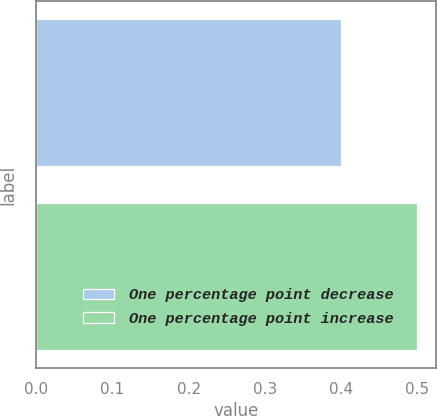Convert chart to OTSL. <chart><loc_0><loc_0><loc_500><loc_500><bar_chart><fcel>One percentage point decrease<fcel>One percentage point increase<nl><fcel>0.4<fcel>0.5<nl></chart> 